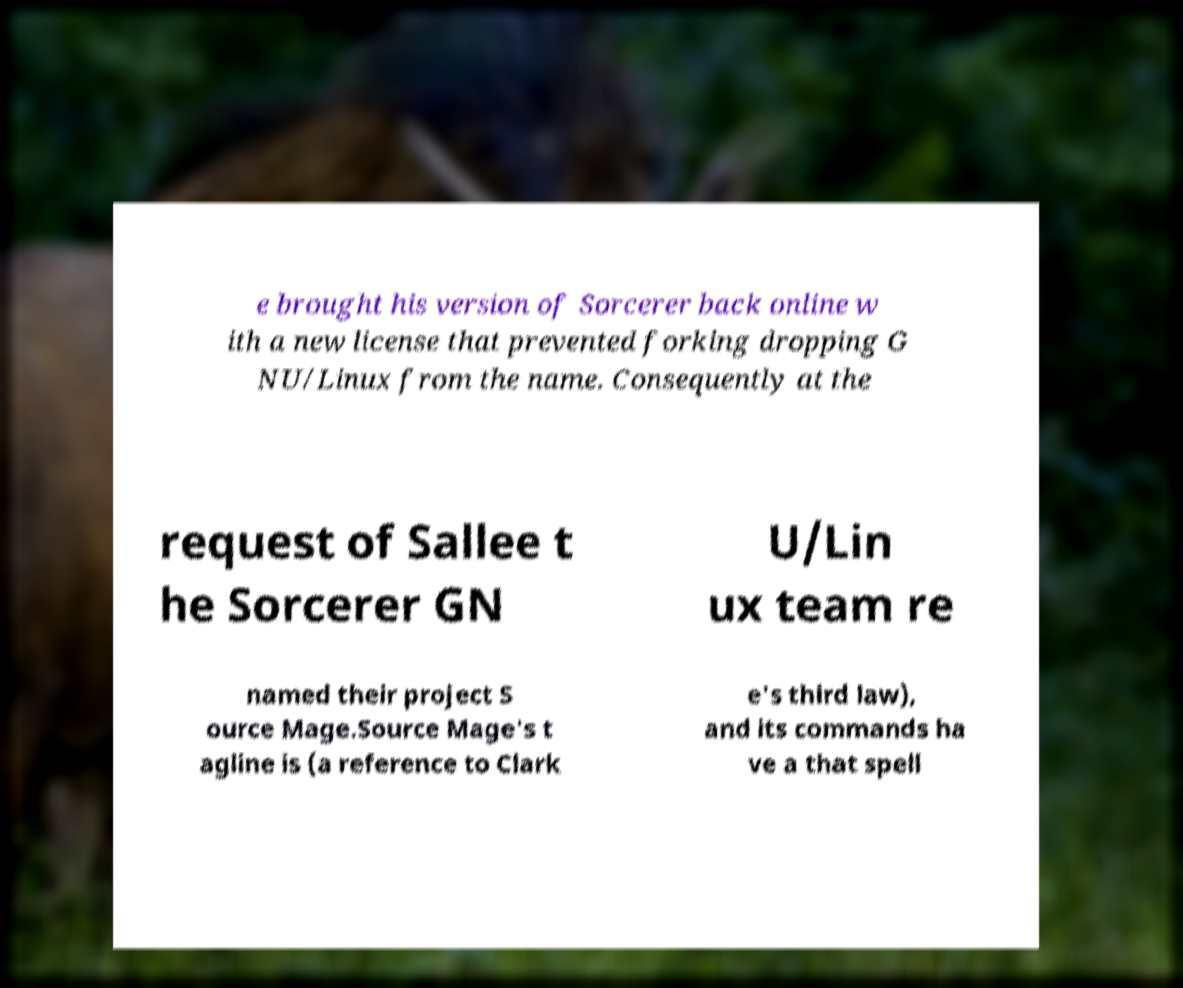Please identify and transcribe the text found in this image. e brought his version of Sorcerer back online w ith a new license that prevented forking dropping G NU/Linux from the name. Consequently at the request of Sallee t he Sorcerer GN U/Lin ux team re named their project S ource Mage.Source Mage's t agline is (a reference to Clark e's third law), and its commands ha ve a that spell 